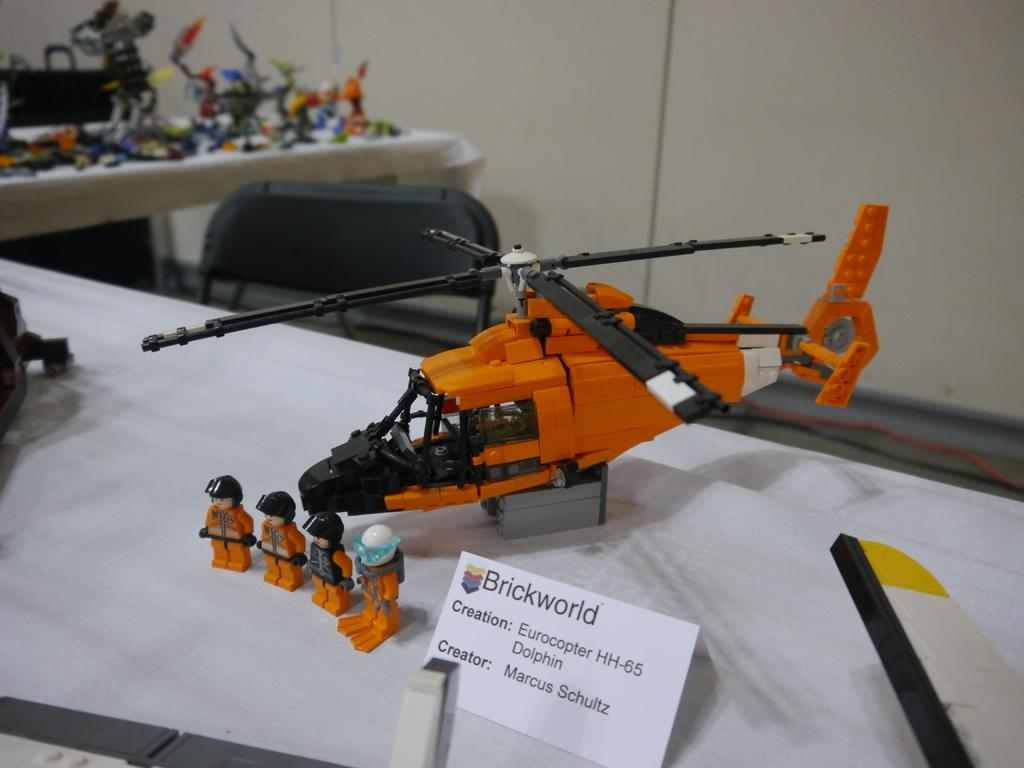<image>
Give a short and clear explanation of the subsequent image. the name brickworld is next to a helicopter 